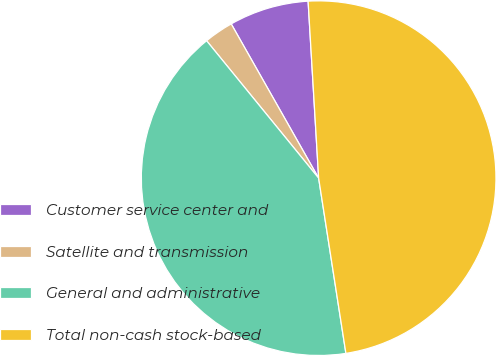Convert chart to OTSL. <chart><loc_0><loc_0><loc_500><loc_500><pie_chart><fcel>Customer service center and<fcel>Satellite and transmission<fcel>General and administrative<fcel>Total non-cash stock-based<nl><fcel>7.26%<fcel>2.68%<fcel>41.57%<fcel>48.49%<nl></chart> 